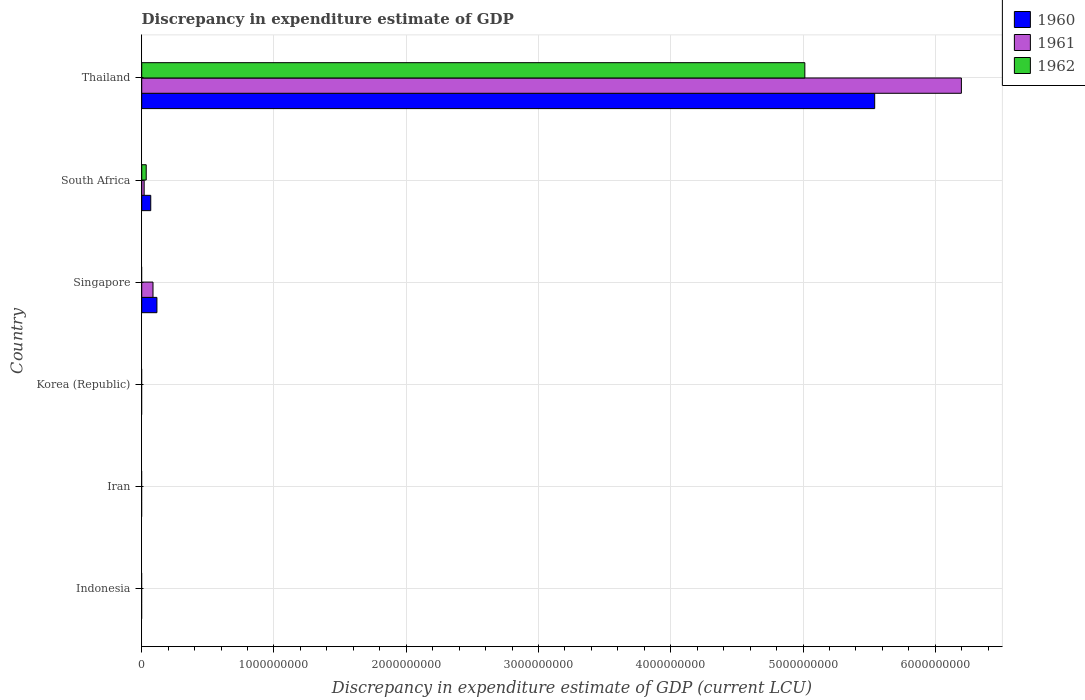How many different coloured bars are there?
Keep it short and to the point. 3. Are the number of bars per tick equal to the number of legend labels?
Make the answer very short. No. How many bars are there on the 1st tick from the top?
Offer a terse response. 3. What is the label of the 2nd group of bars from the top?
Your response must be concise. South Africa. What is the discrepancy in expenditure estimate of GDP in 1960 in Singapore?
Provide a short and direct response. 1.15e+08. Across all countries, what is the maximum discrepancy in expenditure estimate of GDP in 1961?
Ensure brevity in your answer.  6.20e+09. In which country was the discrepancy in expenditure estimate of GDP in 1960 maximum?
Your answer should be very brief. Thailand. What is the total discrepancy in expenditure estimate of GDP in 1961 in the graph?
Your answer should be compact. 6.30e+09. What is the difference between the discrepancy in expenditure estimate of GDP in 1961 in Singapore and that in South Africa?
Offer a terse response. 6.69e+07. What is the difference between the discrepancy in expenditure estimate of GDP in 1960 in South Africa and the discrepancy in expenditure estimate of GDP in 1961 in Singapore?
Give a very brief answer. -1.70e+07. What is the average discrepancy in expenditure estimate of GDP in 1961 per country?
Offer a terse response. 1.05e+09. What is the difference between the discrepancy in expenditure estimate of GDP in 1961 and discrepancy in expenditure estimate of GDP in 1960 in South Africa?
Your response must be concise. -4.99e+07. In how many countries, is the discrepancy in expenditure estimate of GDP in 1961 greater than 5600000000 LCU?
Offer a terse response. 1. What is the ratio of the discrepancy in expenditure estimate of GDP in 1961 in Singapore to that in Thailand?
Ensure brevity in your answer.  0.01. What is the difference between the highest and the second highest discrepancy in expenditure estimate of GDP in 1961?
Your answer should be compact. 6.11e+09. What is the difference between the highest and the lowest discrepancy in expenditure estimate of GDP in 1961?
Offer a very short reply. 6.20e+09. In how many countries, is the discrepancy in expenditure estimate of GDP in 1960 greater than the average discrepancy in expenditure estimate of GDP in 1960 taken over all countries?
Keep it short and to the point. 1. How many bars are there?
Your answer should be compact. 8. Are all the bars in the graph horizontal?
Keep it short and to the point. Yes. Does the graph contain grids?
Give a very brief answer. Yes. How many legend labels are there?
Your answer should be compact. 3. How are the legend labels stacked?
Keep it short and to the point. Vertical. What is the title of the graph?
Provide a succinct answer. Discrepancy in expenditure estimate of GDP. What is the label or title of the X-axis?
Offer a very short reply. Discrepancy in expenditure estimate of GDP (current LCU). What is the Discrepancy in expenditure estimate of GDP (current LCU) of 1960 in Iran?
Offer a terse response. 0. What is the Discrepancy in expenditure estimate of GDP (current LCU) in 1961 in Iran?
Provide a succinct answer. 0. What is the Discrepancy in expenditure estimate of GDP (current LCU) in 1960 in Korea (Republic)?
Offer a very short reply. 0. What is the Discrepancy in expenditure estimate of GDP (current LCU) in 1961 in Korea (Republic)?
Keep it short and to the point. 0. What is the Discrepancy in expenditure estimate of GDP (current LCU) of 1960 in Singapore?
Make the answer very short. 1.15e+08. What is the Discrepancy in expenditure estimate of GDP (current LCU) of 1961 in Singapore?
Provide a succinct answer. 8.53e+07. What is the Discrepancy in expenditure estimate of GDP (current LCU) of 1962 in Singapore?
Provide a short and direct response. 0. What is the Discrepancy in expenditure estimate of GDP (current LCU) in 1960 in South Africa?
Keep it short and to the point. 6.83e+07. What is the Discrepancy in expenditure estimate of GDP (current LCU) in 1961 in South Africa?
Make the answer very short. 1.84e+07. What is the Discrepancy in expenditure estimate of GDP (current LCU) in 1962 in South Africa?
Your answer should be very brief. 3.40e+07. What is the Discrepancy in expenditure estimate of GDP (current LCU) of 1960 in Thailand?
Your answer should be compact. 5.54e+09. What is the Discrepancy in expenditure estimate of GDP (current LCU) in 1961 in Thailand?
Your response must be concise. 6.20e+09. What is the Discrepancy in expenditure estimate of GDP (current LCU) in 1962 in Thailand?
Your response must be concise. 5.01e+09. Across all countries, what is the maximum Discrepancy in expenditure estimate of GDP (current LCU) in 1960?
Provide a short and direct response. 5.54e+09. Across all countries, what is the maximum Discrepancy in expenditure estimate of GDP (current LCU) of 1961?
Your response must be concise. 6.20e+09. Across all countries, what is the maximum Discrepancy in expenditure estimate of GDP (current LCU) of 1962?
Keep it short and to the point. 5.01e+09. Across all countries, what is the minimum Discrepancy in expenditure estimate of GDP (current LCU) in 1960?
Provide a succinct answer. 0. Across all countries, what is the minimum Discrepancy in expenditure estimate of GDP (current LCU) in 1961?
Offer a terse response. 0. Across all countries, what is the minimum Discrepancy in expenditure estimate of GDP (current LCU) of 1962?
Your answer should be very brief. 0. What is the total Discrepancy in expenditure estimate of GDP (current LCU) in 1960 in the graph?
Offer a terse response. 5.72e+09. What is the total Discrepancy in expenditure estimate of GDP (current LCU) of 1961 in the graph?
Keep it short and to the point. 6.30e+09. What is the total Discrepancy in expenditure estimate of GDP (current LCU) of 1962 in the graph?
Make the answer very short. 5.05e+09. What is the difference between the Discrepancy in expenditure estimate of GDP (current LCU) in 1960 in Singapore and that in South Africa?
Keep it short and to the point. 4.66e+07. What is the difference between the Discrepancy in expenditure estimate of GDP (current LCU) in 1961 in Singapore and that in South Africa?
Your answer should be compact. 6.69e+07. What is the difference between the Discrepancy in expenditure estimate of GDP (current LCU) of 1960 in Singapore and that in Thailand?
Your answer should be very brief. -5.43e+09. What is the difference between the Discrepancy in expenditure estimate of GDP (current LCU) of 1961 in Singapore and that in Thailand?
Make the answer very short. -6.11e+09. What is the difference between the Discrepancy in expenditure estimate of GDP (current LCU) in 1960 in South Africa and that in Thailand?
Give a very brief answer. -5.47e+09. What is the difference between the Discrepancy in expenditure estimate of GDP (current LCU) of 1961 in South Africa and that in Thailand?
Offer a very short reply. -6.18e+09. What is the difference between the Discrepancy in expenditure estimate of GDP (current LCU) in 1962 in South Africa and that in Thailand?
Offer a terse response. -4.98e+09. What is the difference between the Discrepancy in expenditure estimate of GDP (current LCU) of 1960 in Singapore and the Discrepancy in expenditure estimate of GDP (current LCU) of 1961 in South Africa?
Your answer should be very brief. 9.65e+07. What is the difference between the Discrepancy in expenditure estimate of GDP (current LCU) in 1960 in Singapore and the Discrepancy in expenditure estimate of GDP (current LCU) in 1962 in South Africa?
Offer a very short reply. 8.09e+07. What is the difference between the Discrepancy in expenditure estimate of GDP (current LCU) of 1961 in Singapore and the Discrepancy in expenditure estimate of GDP (current LCU) of 1962 in South Africa?
Keep it short and to the point. 5.13e+07. What is the difference between the Discrepancy in expenditure estimate of GDP (current LCU) in 1960 in Singapore and the Discrepancy in expenditure estimate of GDP (current LCU) in 1961 in Thailand?
Offer a terse response. -6.08e+09. What is the difference between the Discrepancy in expenditure estimate of GDP (current LCU) of 1960 in Singapore and the Discrepancy in expenditure estimate of GDP (current LCU) of 1962 in Thailand?
Provide a short and direct response. -4.90e+09. What is the difference between the Discrepancy in expenditure estimate of GDP (current LCU) of 1961 in Singapore and the Discrepancy in expenditure estimate of GDP (current LCU) of 1962 in Thailand?
Offer a terse response. -4.93e+09. What is the difference between the Discrepancy in expenditure estimate of GDP (current LCU) in 1960 in South Africa and the Discrepancy in expenditure estimate of GDP (current LCU) in 1961 in Thailand?
Ensure brevity in your answer.  -6.13e+09. What is the difference between the Discrepancy in expenditure estimate of GDP (current LCU) in 1960 in South Africa and the Discrepancy in expenditure estimate of GDP (current LCU) in 1962 in Thailand?
Your response must be concise. -4.95e+09. What is the difference between the Discrepancy in expenditure estimate of GDP (current LCU) of 1961 in South Africa and the Discrepancy in expenditure estimate of GDP (current LCU) of 1962 in Thailand?
Offer a very short reply. -5.00e+09. What is the average Discrepancy in expenditure estimate of GDP (current LCU) of 1960 per country?
Your answer should be compact. 9.54e+08. What is the average Discrepancy in expenditure estimate of GDP (current LCU) of 1961 per country?
Offer a very short reply. 1.05e+09. What is the average Discrepancy in expenditure estimate of GDP (current LCU) in 1962 per country?
Your answer should be very brief. 8.41e+08. What is the difference between the Discrepancy in expenditure estimate of GDP (current LCU) in 1960 and Discrepancy in expenditure estimate of GDP (current LCU) in 1961 in Singapore?
Your answer should be very brief. 2.96e+07. What is the difference between the Discrepancy in expenditure estimate of GDP (current LCU) in 1960 and Discrepancy in expenditure estimate of GDP (current LCU) in 1961 in South Africa?
Your answer should be very brief. 4.99e+07. What is the difference between the Discrepancy in expenditure estimate of GDP (current LCU) in 1960 and Discrepancy in expenditure estimate of GDP (current LCU) in 1962 in South Africa?
Give a very brief answer. 3.43e+07. What is the difference between the Discrepancy in expenditure estimate of GDP (current LCU) in 1961 and Discrepancy in expenditure estimate of GDP (current LCU) in 1962 in South Africa?
Offer a very short reply. -1.56e+07. What is the difference between the Discrepancy in expenditure estimate of GDP (current LCU) in 1960 and Discrepancy in expenditure estimate of GDP (current LCU) in 1961 in Thailand?
Provide a succinct answer. -6.56e+08. What is the difference between the Discrepancy in expenditure estimate of GDP (current LCU) in 1960 and Discrepancy in expenditure estimate of GDP (current LCU) in 1962 in Thailand?
Your response must be concise. 5.28e+08. What is the difference between the Discrepancy in expenditure estimate of GDP (current LCU) in 1961 and Discrepancy in expenditure estimate of GDP (current LCU) in 1962 in Thailand?
Your answer should be compact. 1.18e+09. What is the ratio of the Discrepancy in expenditure estimate of GDP (current LCU) in 1960 in Singapore to that in South Africa?
Give a very brief answer. 1.68. What is the ratio of the Discrepancy in expenditure estimate of GDP (current LCU) of 1961 in Singapore to that in South Africa?
Provide a succinct answer. 4.64. What is the ratio of the Discrepancy in expenditure estimate of GDP (current LCU) of 1960 in Singapore to that in Thailand?
Give a very brief answer. 0.02. What is the ratio of the Discrepancy in expenditure estimate of GDP (current LCU) of 1961 in Singapore to that in Thailand?
Ensure brevity in your answer.  0.01. What is the ratio of the Discrepancy in expenditure estimate of GDP (current LCU) of 1960 in South Africa to that in Thailand?
Ensure brevity in your answer.  0.01. What is the ratio of the Discrepancy in expenditure estimate of GDP (current LCU) of 1961 in South Africa to that in Thailand?
Your answer should be compact. 0. What is the ratio of the Discrepancy in expenditure estimate of GDP (current LCU) of 1962 in South Africa to that in Thailand?
Offer a very short reply. 0.01. What is the difference between the highest and the second highest Discrepancy in expenditure estimate of GDP (current LCU) of 1960?
Make the answer very short. 5.43e+09. What is the difference between the highest and the second highest Discrepancy in expenditure estimate of GDP (current LCU) of 1961?
Give a very brief answer. 6.11e+09. What is the difference between the highest and the lowest Discrepancy in expenditure estimate of GDP (current LCU) of 1960?
Offer a very short reply. 5.54e+09. What is the difference between the highest and the lowest Discrepancy in expenditure estimate of GDP (current LCU) in 1961?
Provide a short and direct response. 6.20e+09. What is the difference between the highest and the lowest Discrepancy in expenditure estimate of GDP (current LCU) in 1962?
Give a very brief answer. 5.01e+09. 